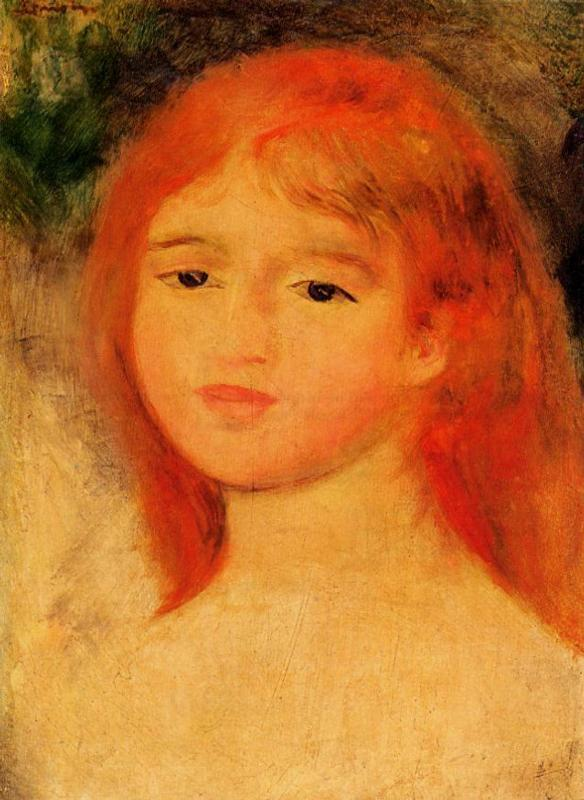What emotions might the artist be trying to convey through the girl's expression in this painting? The artist seems to convey a mixture of tranquility and introspection through the girl's expression. The soft eyes, subtly parted lips, and the overall serene ambiance suggest a moment of quiet reflection, perhaps hinting at a young mind pondering over simple yet profound thoughts of her early experiences in life. The gentleness in her pose and the warmth in her blush evoke a sense of calmness and gentle joy. 